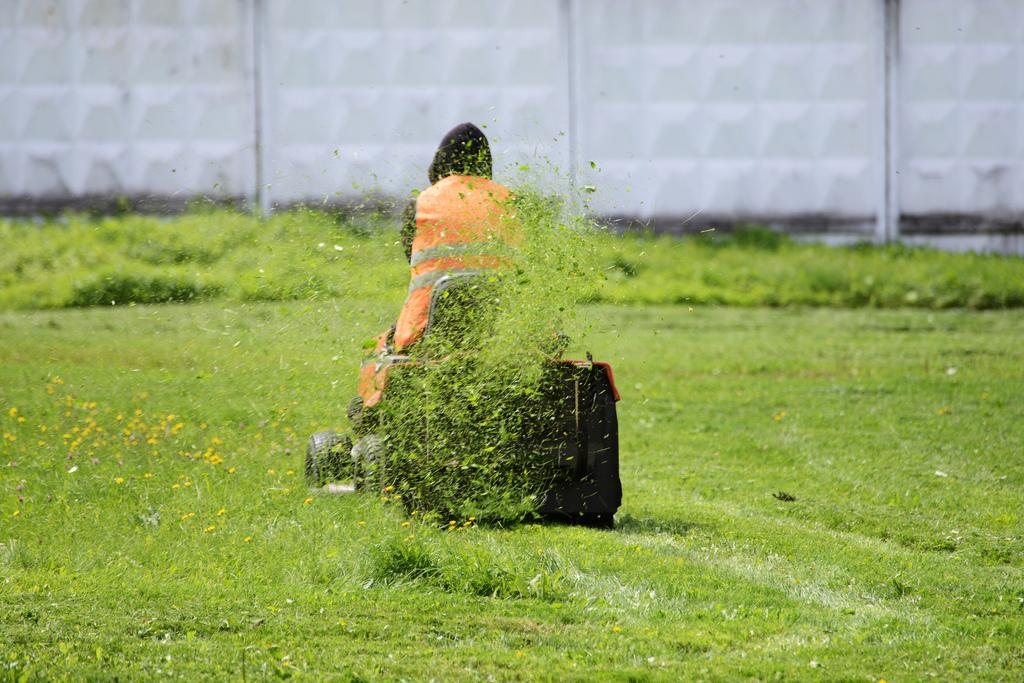What is the person in the image doing? The person is cutting grass. What tool is the person using to cut the grass? The person is using a lawn mower. What can be seen in the background of the image? There is a wall visible in the image. What type of bait is the person using to catch fish in the image? There is no indication of fishing or bait in the image; the person is cutting grass with a lawn mower. 